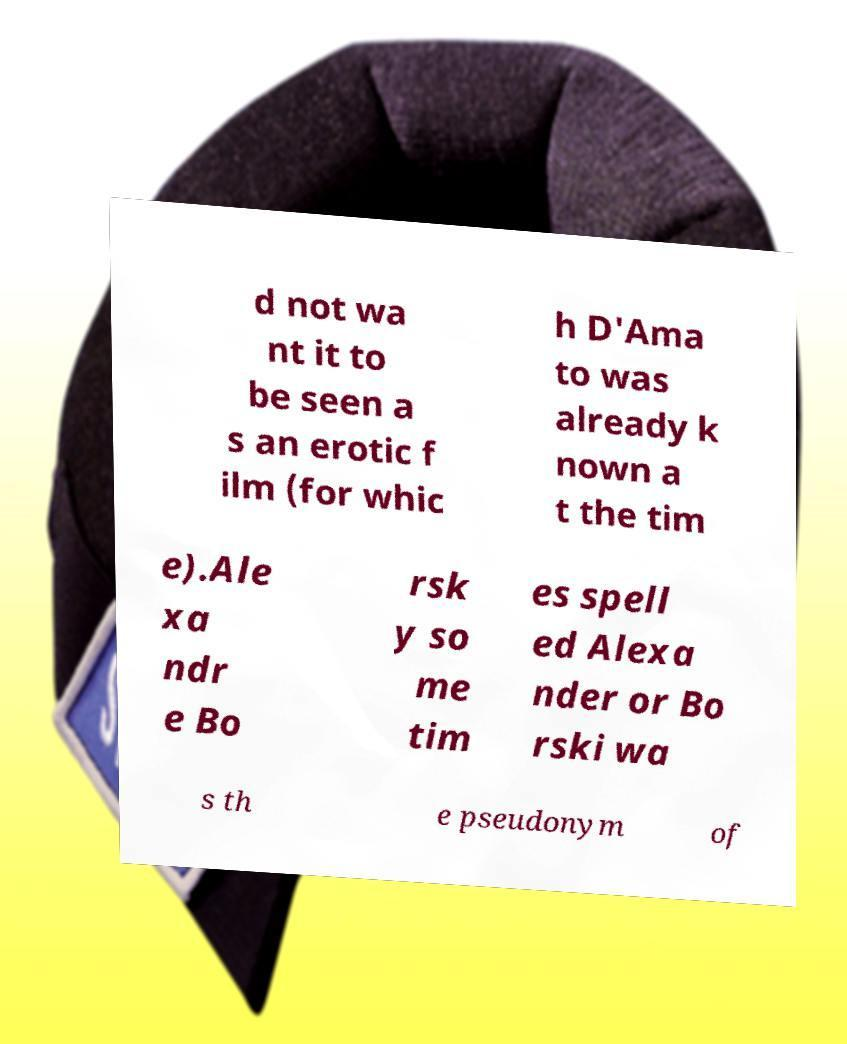For documentation purposes, I need the text within this image transcribed. Could you provide that? d not wa nt it to be seen a s an erotic f ilm (for whic h D'Ama to was already k nown a t the tim e).Ale xa ndr e Bo rsk y so me tim es spell ed Alexa nder or Bo rski wa s th e pseudonym of 